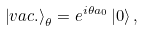<formula> <loc_0><loc_0><loc_500><loc_500>\left | v a c . \right > _ { \theta } = e ^ { i \theta a _ { 0 } } \left | 0 \right > ,</formula> 